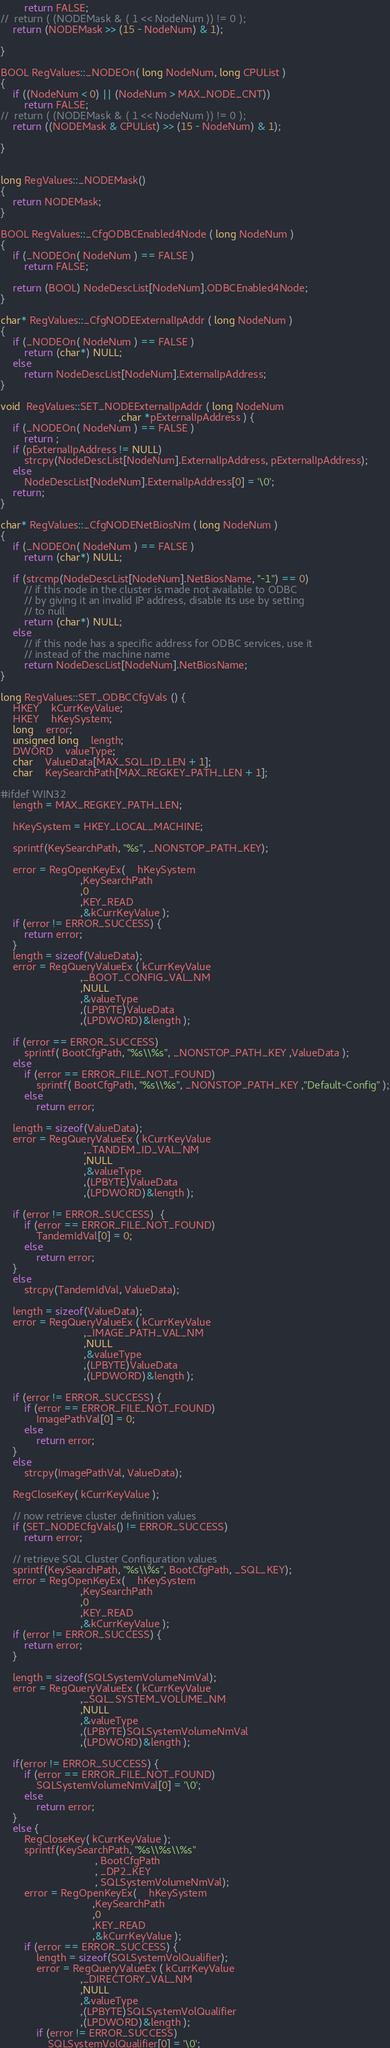Convert code to text. <code><loc_0><loc_0><loc_500><loc_500><_C++_>		return FALSE;
//	return ( (NODEMask & ( 1 << NodeNum )) != 0 );
	return (NODEMask >> (15 - NodeNum) & 1);

}

BOOL RegValues::_NODEOn( long NodeNum, long CPUList )
{
	if ((NodeNum < 0) || (NodeNum > MAX_NODE_CNT))
		return FALSE;
//	return ( (NODEMask & ( 1 << NodeNum )) != 0 );
	return ((NODEMask & CPUList) >> (15 - NodeNum) & 1);

}


long RegValues::_NODEMask()
{
	return NODEMask;
}

BOOL RegValues::_CfgODBCEnabled4Node ( long NodeNum )
{
	if (_NODEOn( NodeNum ) == FALSE )
	    return FALSE;

	return (BOOL) NodeDescList[NodeNum].ODBCEnabled4Node;
}

char* RegValues::_CfgNODEExternalIpAddr ( long NodeNum )
{
	if (_NODEOn( NodeNum ) == FALSE )
	    return (char*) NULL;
	else
		return NodeDescList[NodeNum].ExternalIpAddress;
}

void  RegValues::SET_NODEExternalIpAddr ( long NodeNum
										,char *pExternalIpAddress ) {
	if (_NODEOn( NodeNum ) == FALSE )
	    return ;
	if (pExternalIpAddress != NULL)
		strcpy(NodeDescList[NodeNum].ExternalIpAddress, pExternalIpAddress);
	else
		NodeDescList[NodeNum].ExternalIpAddress[0] = '\0';
	return;
}

char* RegValues::_CfgNODENetBiosNm ( long NodeNum )
{
	if (_NODEOn( NodeNum ) == FALSE )
	    return (char*) NULL;

	if (strcmp(NodeDescList[NodeNum].NetBiosName, "-1") == 0)
		// if this node in the cluster is made not available to ODBC
		// by giving it an invalid IP address, disable its use by setting
		// to null
		return (char*) NULL;
	else
		// if this node has a specific address for ODBC services, use it
		// instead of the machine name
		return NodeDescList[NodeNum].NetBiosName;
}

long RegValues::SET_ODBCCfgVals () {
	HKEY	kCurrKeyValue;
	HKEY	hKeySystem;
	long	error;
	unsigned long	length;
	DWORD	valueType;
	char	ValueData[MAX_SQL_ID_LEN + 1];
	char	KeySearchPath[MAX_REGKEY_PATH_LEN + 1];

#ifdef WIN32
	length = MAX_REGKEY_PATH_LEN;

	hKeySystem = HKEY_LOCAL_MACHINE;

	sprintf(KeySearchPath, "%s", _NONSTOP_PATH_KEY);

	error = RegOpenKeyEx(	hKeySystem
						   ,KeySearchPath
						   ,0
						   ,KEY_READ
						   ,&kCurrKeyValue );
	if (error != ERROR_SUCCESS) {
		return error;
	}
	length = sizeof(ValueData);
	error = RegQueryValueEx ( kCurrKeyValue
	                       ,_BOOT_CONFIG_VAL_NM
						   ,NULL
						   ,&valueType
						   ,(LPBYTE)ValueData
						   ,(LPDWORD)&length );

    if (error == ERROR_SUCCESS)
		sprintf( BootCfgPath, "%s\\%s", _NONSTOP_PATH_KEY ,ValueData );
	else
		if (error == ERROR_FILE_NOT_FOUND)
			sprintf( BootCfgPath, "%s\\%s", _NONSTOP_PATH_KEY ,"Default-Config" );
		else
			return error;

	length = sizeof(ValueData);
	error = RegQueryValueEx ( kCurrKeyValue
							,_TANDEM_ID_VAL_NM
							,NULL
							,&valueType
							,(LPBYTE)ValueData
							,(LPDWORD)&length );

	if (error != ERROR_SUCCESS)  {
		if (error == ERROR_FILE_NOT_FOUND)
			TandemIdVal[0] = 0;
		else
			return error;
	}
	else
		strcpy(TandemIdVal, ValueData);

	length = sizeof(ValueData);
	error = RegQueryValueEx ( kCurrKeyValue
							,_IMAGE_PATH_VAL_NM
							,NULL
							,&valueType
							,(LPBYTE)ValueData
							,(LPDWORD)&length );

	if (error != ERROR_SUCCESS) {
		if (error == ERROR_FILE_NOT_FOUND)
			ImagePathVal[0] = 0;
		else
			return error;
	}
	else
		strcpy(ImagePathVal, ValueData);

	RegCloseKey( kCurrKeyValue );

	// now retrieve cluster definition values
	if (SET_NODECfgVals() != ERROR_SUCCESS)
		return error;

	// retrieve SQL Cluster Configuration values
	sprintf(KeySearchPath, "%s\\%s", BootCfgPath, _SQL_KEY);
	error = RegOpenKeyEx(	hKeySystem
						   ,KeySearchPath
						   ,0
						   ,KEY_READ
						   ,&kCurrKeyValue );
	if (error != ERROR_SUCCESS) {
		return error;
	}

	length = sizeof(SQLSystemVolumeNmVal);
	error = RegQueryValueEx ( kCurrKeyValue
	                       ,_SQL_SYSTEM_VOLUME_NM
						   ,NULL
						   ,&valueType
						   ,(LPBYTE)SQLSystemVolumeNmVal
						   ,(LPDWORD)&length );

	if(error != ERROR_SUCCESS) {
		if (error == ERROR_FILE_NOT_FOUND)
			SQLSystemVolumeNmVal[0] = '\0';
		else
			return error;
	}
	else {
		RegCloseKey( kCurrKeyValue );
		sprintf(KeySearchPath, "%s\\%s\\%s"
								, BootCfgPath
								, _DP2_KEY
								, SQLSystemVolumeNmVal);
		error = RegOpenKeyEx(	hKeySystem
							   ,KeySearchPath
							   ,0
							   ,KEY_READ
							   ,&kCurrKeyValue );
		if (error == ERROR_SUCCESS) {
			length = sizeof(SQLSystemVolQualifier);
			error = RegQueryValueEx ( kCurrKeyValue
	                       ,_DIRECTORY_VAL_NM
						   ,NULL
						   ,&valueType
						   ,(LPBYTE)SQLSystemVolQualifier
						   ,(LPDWORD)&length );
			if (error != ERROR_SUCCESS)
				SQLSystemVolQualifier[0] = '\0';</code> 